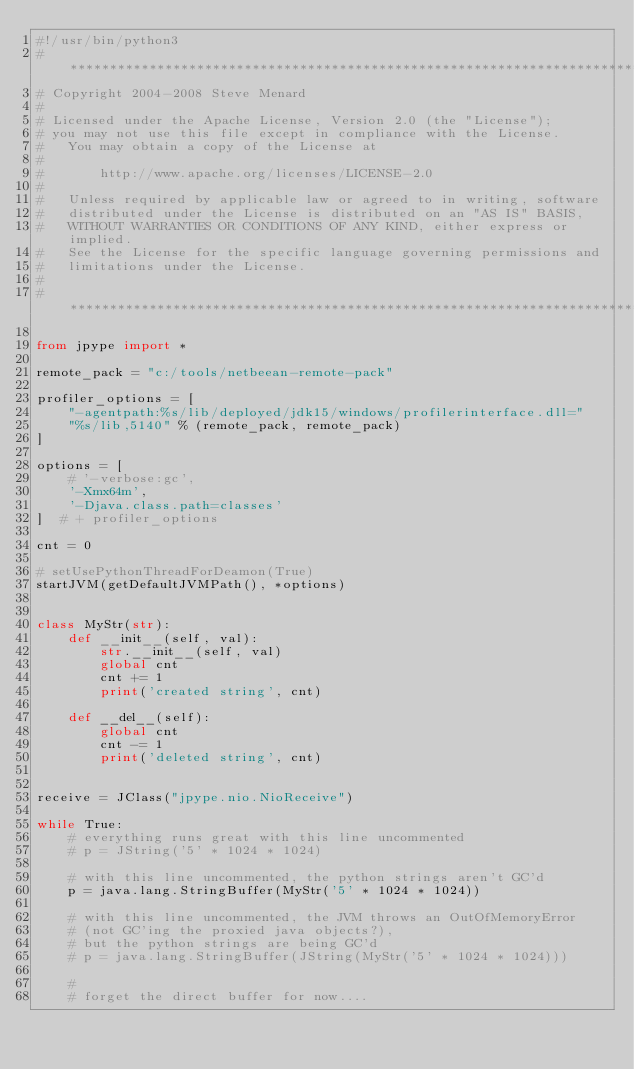<code> <loc_0><loc_0><loc_500><loc_500><_Python_>#!/usr/bin/python3
# *****************************************************************************
# Copyright 2004-2008 Steve Menard
#
# Licensed under the Apache License, Version 2.0 (the "License");
# you may not use this file except in compliance with the License.
#   You may obtain a copy of the License at
#
#       http://www.apache.org/licenses/LICENSE-2.0
#
#   Unless required by applicable law or agreed to in writing, software
#   distributed under the License is distributed on an "AS IS" BASIS,
#   WITHOUT WARRANTIES OR CONDITIONS OF ANY KIND, either express or implied.
#   See the License for the specific language governing permissions and
#   limitations under the License.
#
# *****************************************************************************

from jpype import *

remote_pack = "c:/tools/netbeean-remote-pack"

profiler_options = [
    "-agentpath:%s/lib/deployed/jdk15/windows/profilerinterface.dll="
    "%s/lib,5140" % (remote_pack, remote_pack)
]

options = [
    # '-verbose:gc',
    '-Xmx64m',
    '-Djava.class.path=classes'
]  # + profiler_options

cnt = 0

# setUsePythonThreadForDeamon(True)
startJVM(getDefaultJVMPath(), *options)


class MyStr(str):
    def __init__(self, val):
        str.__init__(self, val)
        global cnt
        cnt += 1
        print('created string', cnt)

    def __del__(self):
        global cnt
        cnt -= 1
        print('deleted string', cnt)


receive = JClass("jpype.nio.NioReceive")

while True:
    # everything runs great with this line uncommented
    # p = JString('5' * 1024 * 1024)

    # with this line uncommented, the python strings aren't GC'd
    p = java.lang.StringBuffer(MyStr('5' * 1024 * 1024))

    # with this line uncommented, the JVM throws an OutOfMemoryError
    # (not GC'ing the proxied java objects?),
    # but the python strings are being GC'd
    # p = java.lang.StringBuffer(JString(MyStr('5' * 1024 * 1024)))

    #
    # forget the direct buffer for now....</code> 